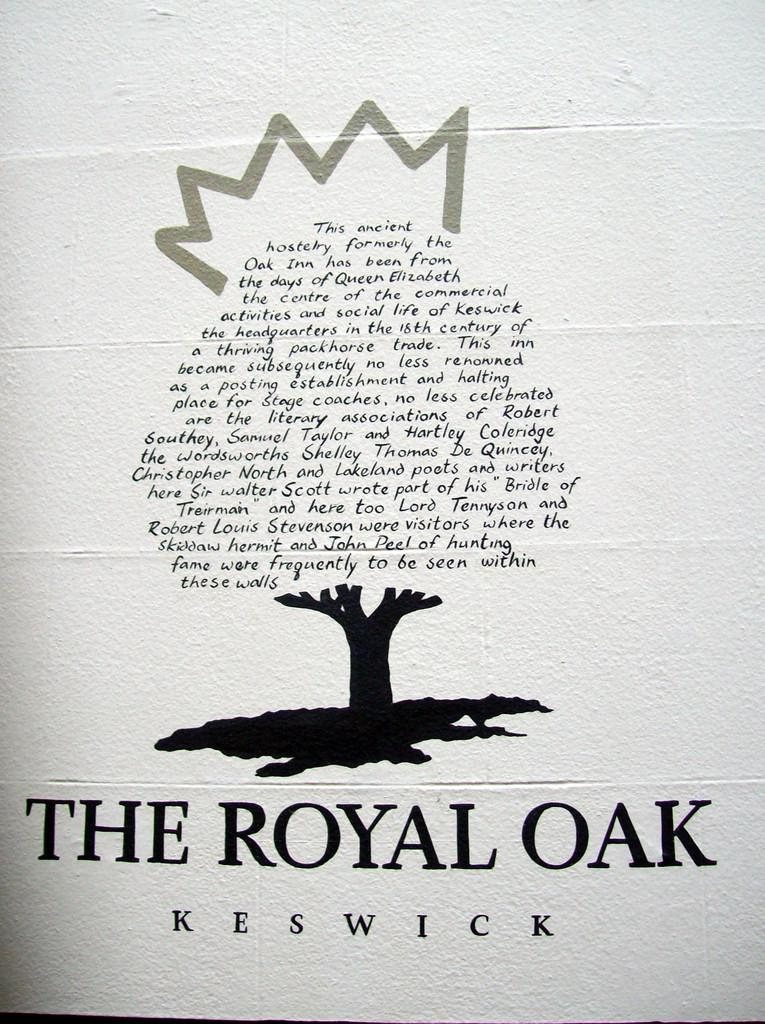<image>
Present a compact description of the photo's key features. A white book has a tree designed on it and has the title the royal oak written on it. 